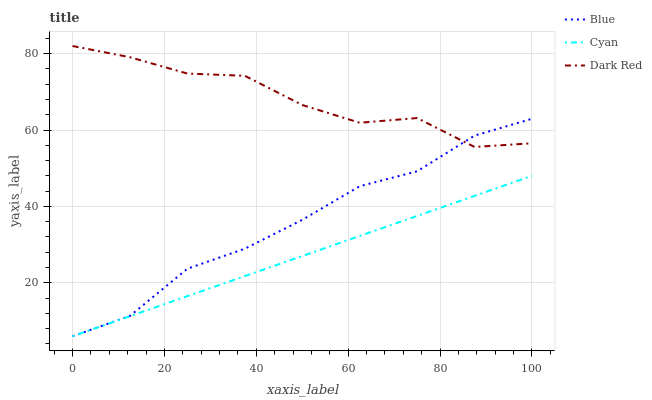Does Cyan have the minimum area under the curve?
Answer yes or no. Yes. Does Dark Red have the maximum area under the curve?
Answer yes or no. Yes. Does Dark Red have the minimum area under the curve?
Answer yes or no. No. Does Cyan have the maximum area under the curve?
Answer yes or no. No. Is Cyan the smoothest?
Answer yes or no. Yes. Is Dark Red the roughest?
Answer yes or no. Yes. Is Dark Red the smoothest?
Answer yes or no. No. Is Cyan the roughest?
Answer yes or no. No. Does Dark Red have the lowest value?
Answer yes or no. No. Does Dark Red have the highest value?
Answer yes or no. Yes. Does Cyan have the highest value?
Answer yes or no. No. Is Cyan less than Dark Red?
Answer yes or no. Yes. Is Dark Red greater than Cyan?
Answer yes or no. Yes. Does Cyan intersect Dark Red?
Answer yes or no. No. 